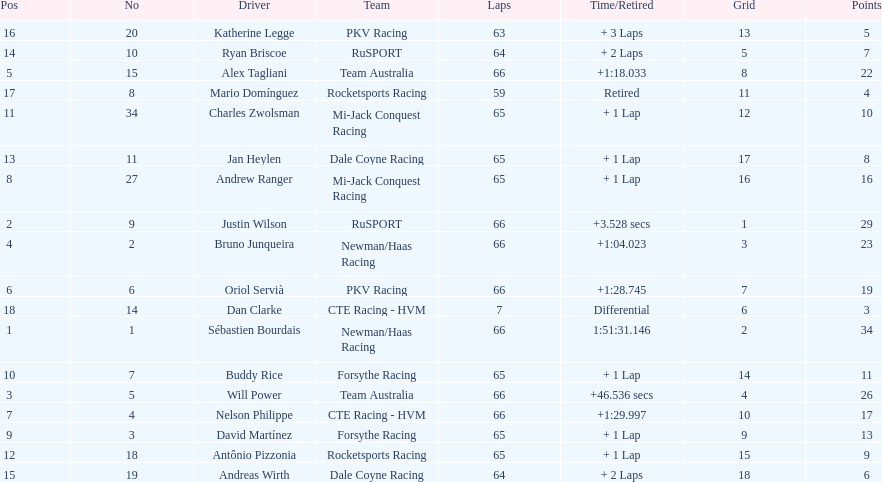How many drivers did not make more than 60 laps? 2. 